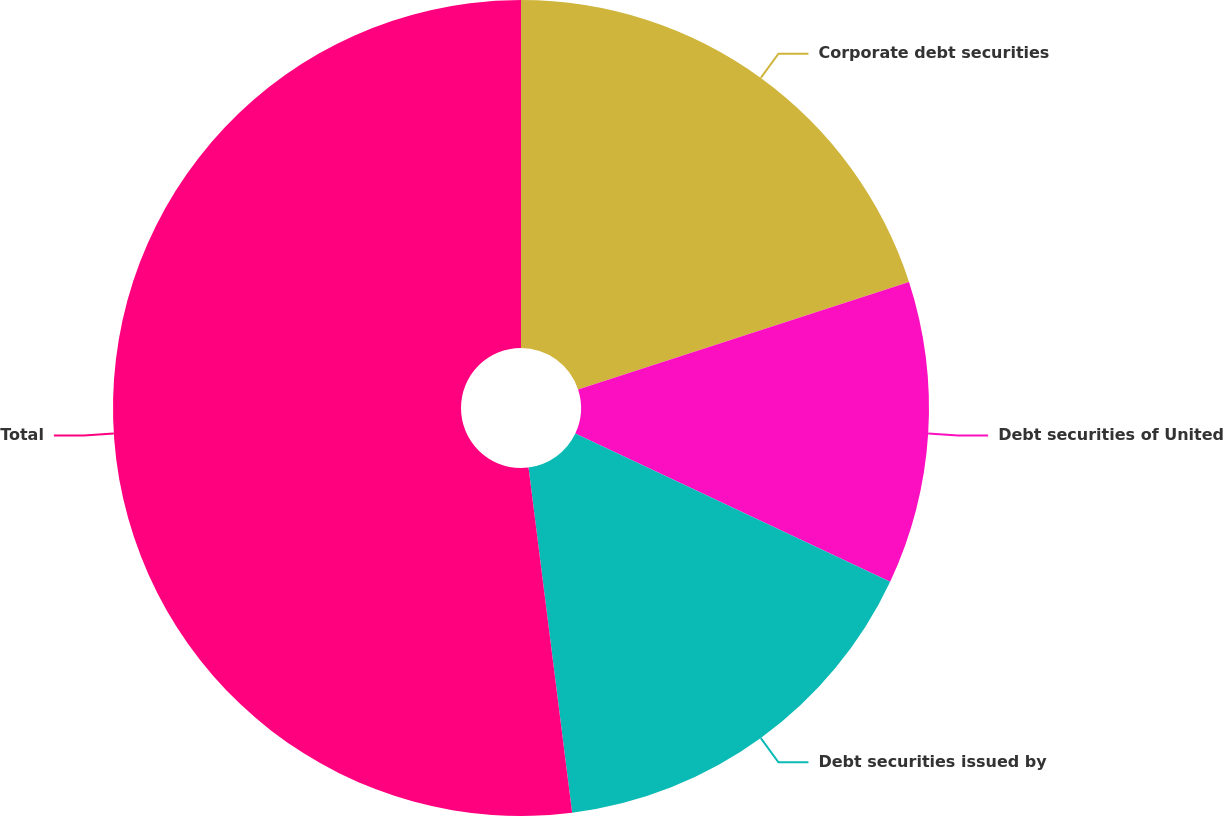Convert chart. <chart><loc_0><loc_0><loc_500><loc_500><pie_chart><fcel>Corporate debt securities<fcel>Debt securities of United<fcel>Debt securities issued by<fcel>Total<nl><fcel>20.0%<fcel>12.0%<fcel>16.0%<fcel>52.0%<nl></chart> 